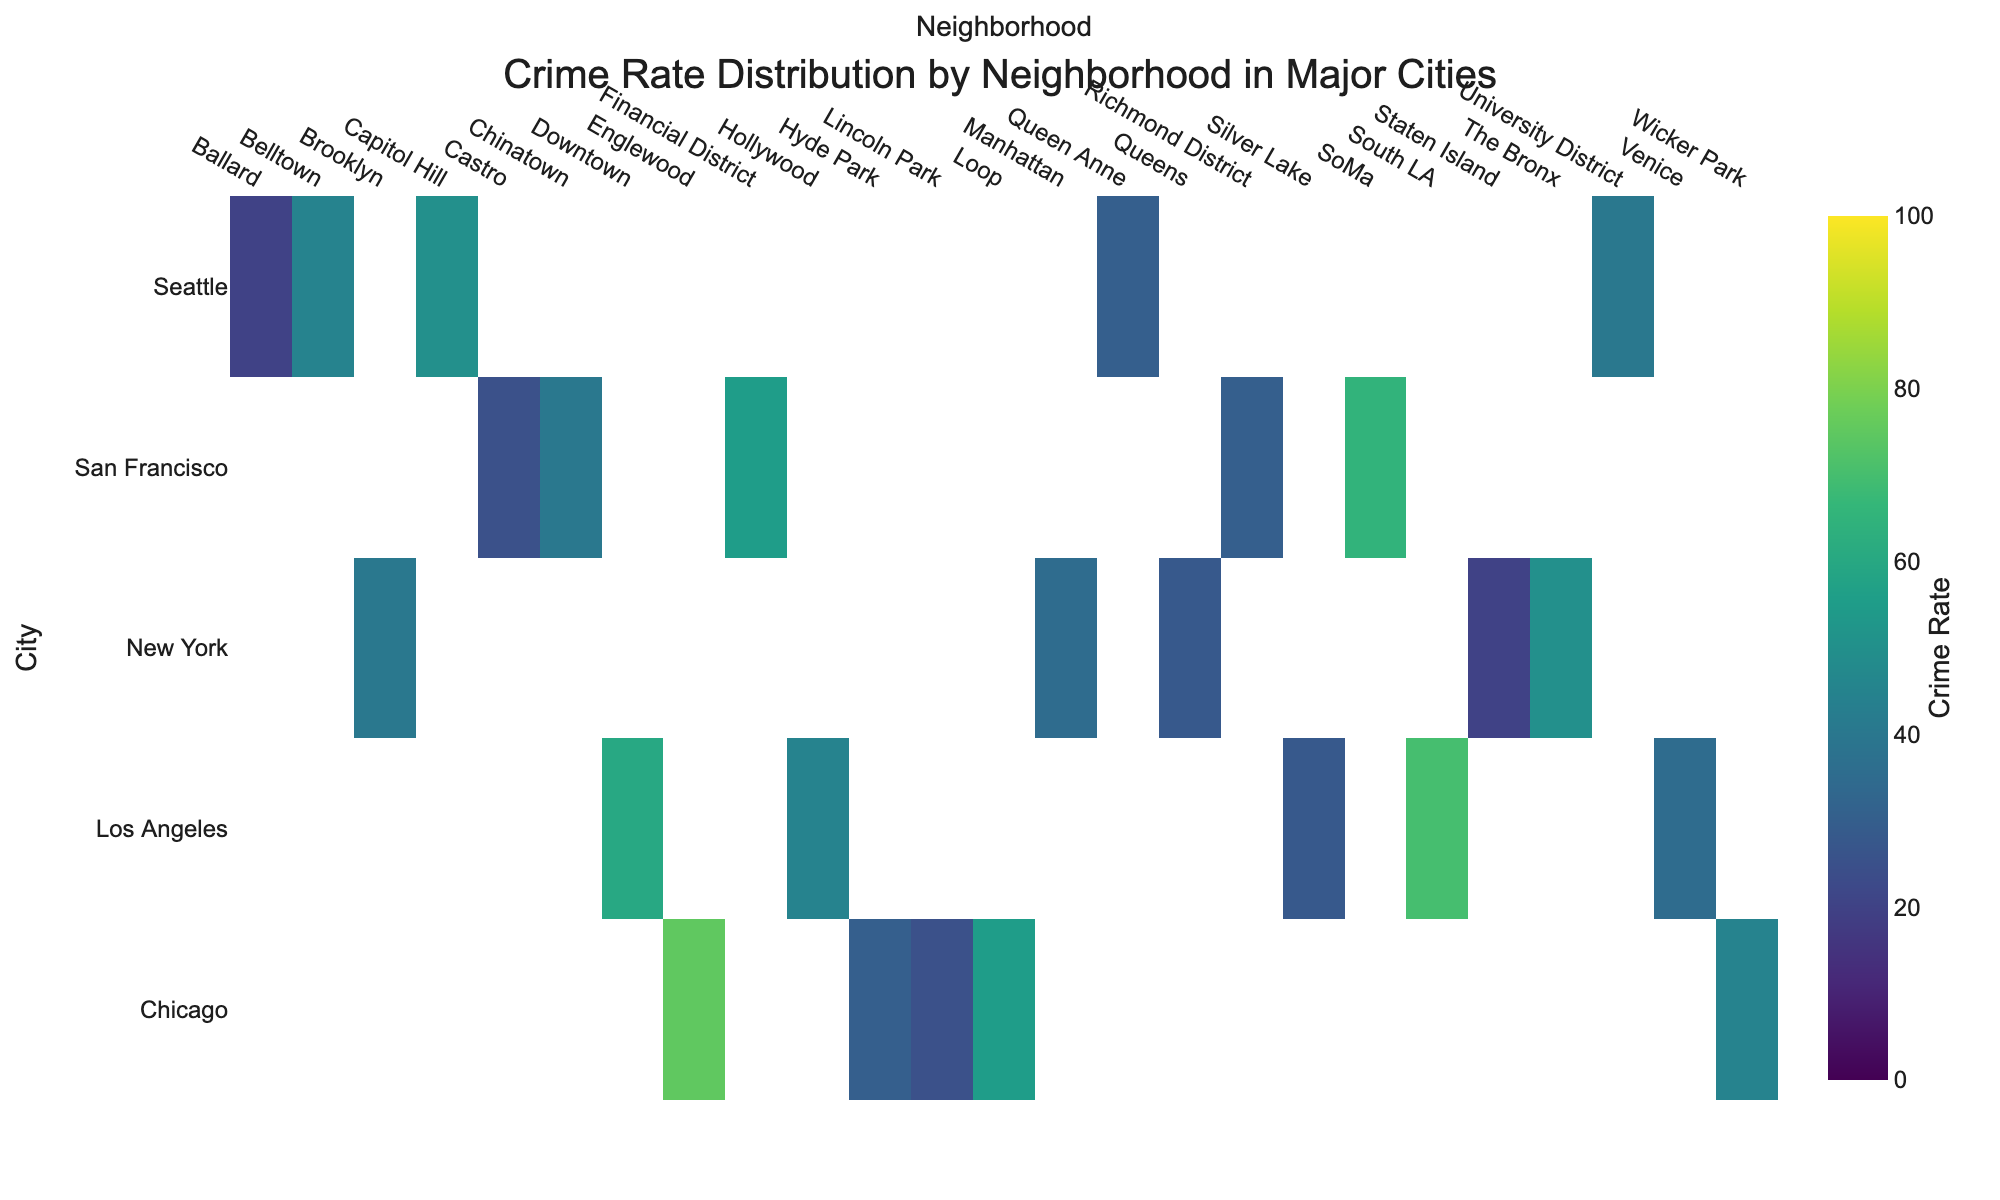What's the title of the figure? The title of the figure is usually displayed prominently at the top of the chart. By looking at the figure, we can see the title written there.
Answer: Crime Rate Distribution by Neighborhood in Major Cities How many cities are represented on the heatmap? We can count the number of cities listed along the y-axis to find the total number of cities represented.
Answer: 5 Which city has the highest crime rate in any neighborhood, and what is that rate? To find the highest crime rate, we look for the cell with the darkest color, indicating the highest value. The highest crime rate is in the Englewood neighborhood of Chicago.
Answer: Chicago, 75 Which neighborhood in Los Angeles has the highest crime rate, and what is that rate? To find the neighborhood with the highest crime rate in Los Angeles, we look at the cells corresponding to Los Angeles and identify the darkest one. The highest crime rate in Los Angeles is in South LA.
Answer: South LA, 70 What's the crime rate difference between Englewood in Chicago and Manhattan in New York? We need to subtract the crime rate in Manhattan from the crime rate in Englewood. Englewood has a crime rate of 75, and Manhattan has a crime rate of 35. The difference is 75 - 35.
Answer: 40 Which neighborhood in Seattle has the lowest crime rate, and what is that rate? By identifying the lightest cell corresponding to Seattle neighborhoods, we can determine that the lowest crime rate is in Ballard.
Answer: Ballard, 20 Is there any neighborhood with a crime rate of exactly 30 in multiple cities? A quick glance at the heatmap reveals that both Lincoln Park in Chicago and Richmond District in San Francisco have crime rates of 30.
Answer: Yes, Lincoln Park and Richmond District What's the average crime rate of the listed neighborhoods in San Francisco? Sum up the crime rates of neighborhoods in San Francisco and divide by the number of neighborhoods. (55 + 40 + 65 + 25 + 30) = 215, then 215 / 5.
Answer: 43 Compare the crime rates of Capitol Hill in Seattle and Financial District in San Francisco. Which one is higher and by how much? Find the crime rates in both neighborhoods and subtract the smaller one from the larger one. Capitol Hill has a rate of 50, and Financial District has a rate of 55. The difference is 55 - 50.
Answer: Financial District, by 5 What's the median crime rate of neighborhoods in New York? List the crime rates in order: 20 (Staten Island), 28 (Queens), 35 (Manhattan), 40 (Brooklyn), 50 (The Bronx). The median is the middle value in this ordered list.
Answer: 35 